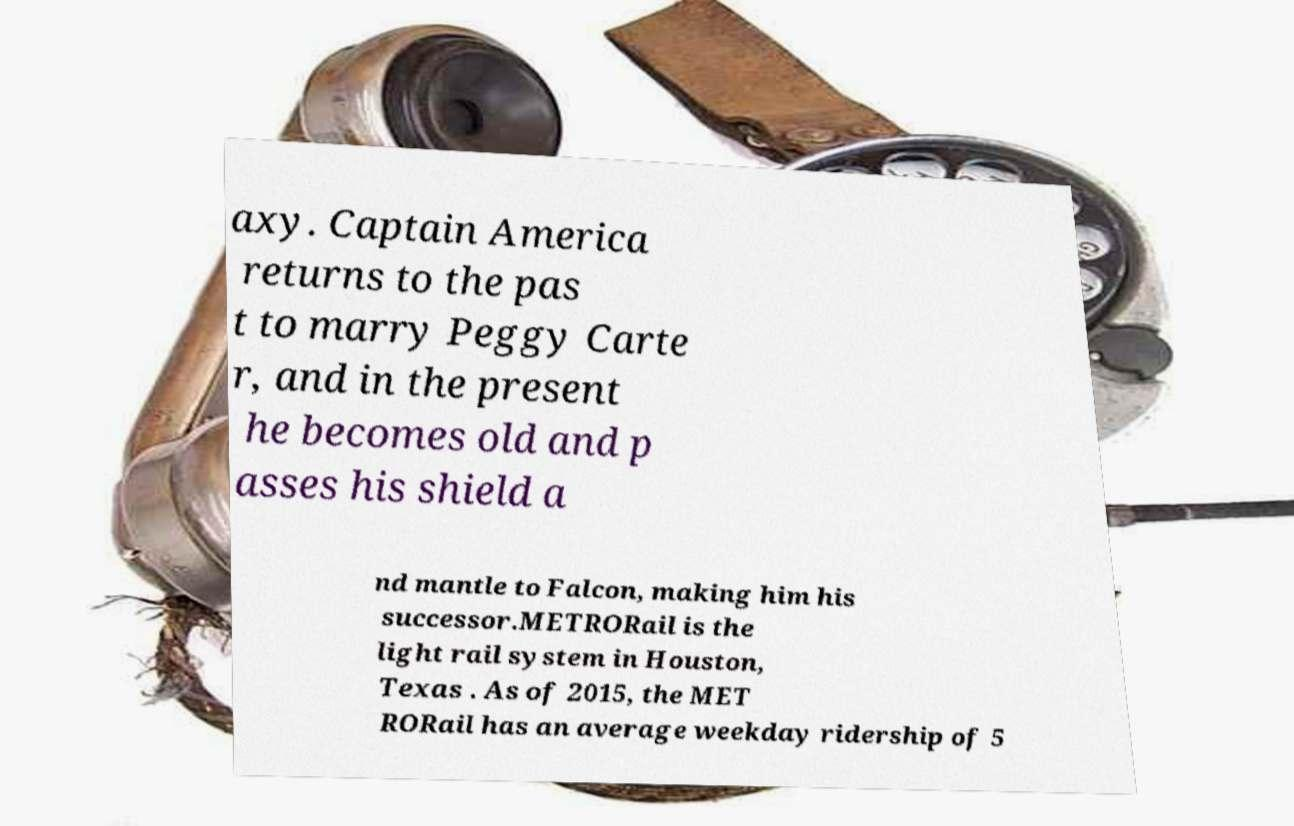Can you accurately transcribe the text from the provided image for me? axy. Captain America returns to the pas t to marry Peggy Carte r, and in the present he becomes old and p asses his shield a nd mantle to Falcon, making him his successor.METRORail is the light rail system in Houston, Texas . As of 2015, the MET RORail has an average weekday ridership of 5 